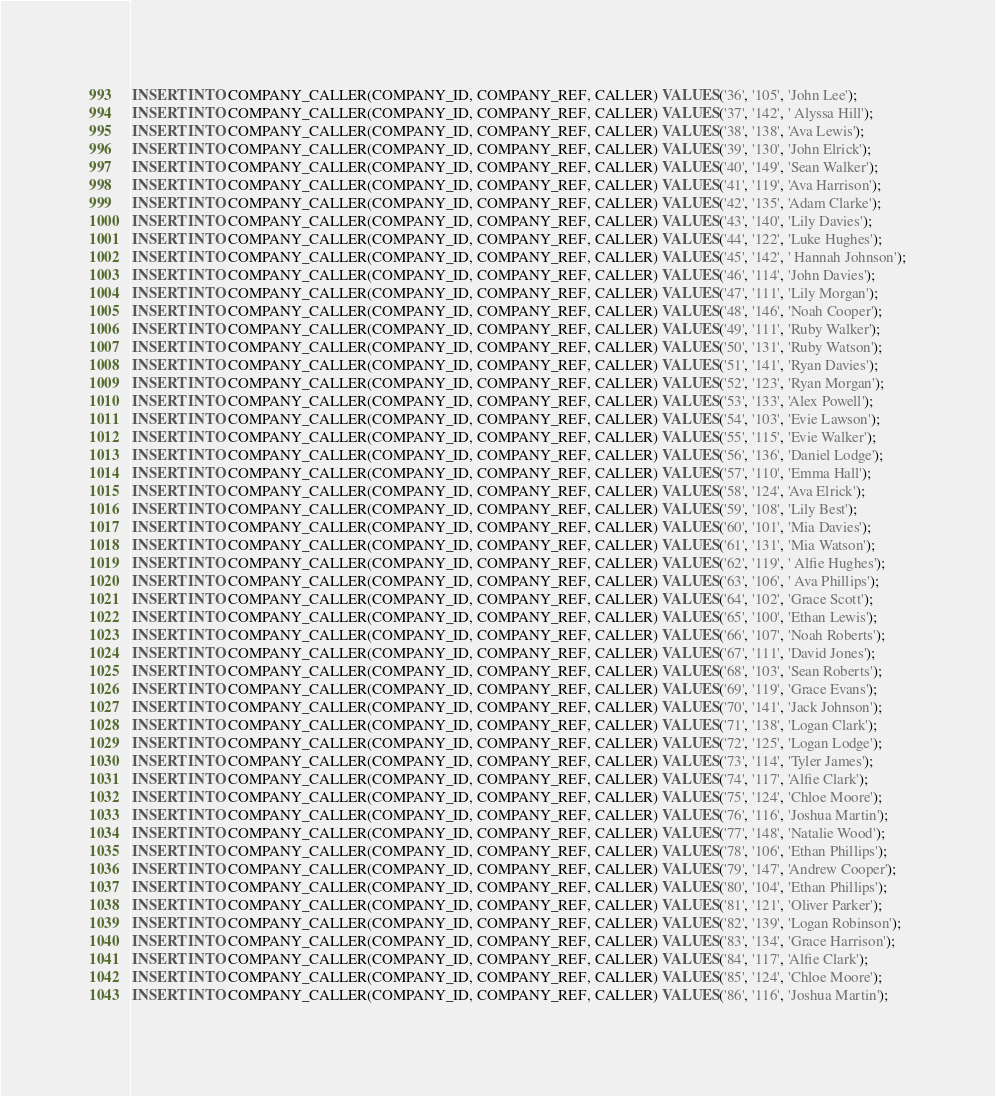<code> <loc_0><loc_0><loc_500><loc_500><_SQL_>INSERT INTO COMPANY_CALLER(COMPANY_ID, COMPANY_REF, CALLER) VALUES('36', '105', 'John Lee');
INSERT INTO COMPANY_CALLER(COMPANY_ID, COMPANY_REF, CALLER) VALUES('37', '142', ' Alyssa Hill');
INSERT INTO COMPANY_CALLER(COMPANY_ID, COMPANY_REF, CALLER) VALUES('38', '138', 'Ava Lewis');
INSERT INTO COMPANY_CALLER(COMPANY_ID, COMPANY_REF, CALLER) VALUES('39', '130', 'John Elrick');
INSERT INTO COMPANY_CALLER(COMPANY_ID, COMPANY_REF, CALLER) VALUES('40', '149', 'Sean Walker');
INSERT INTO COMPANY_CALLER(COMPANY_ID, COMPANY_REF, CALLER) VALUES('41', '119', 'Ava Harrison');
INSERT INTO COMPANY_CALLER(COMPANY_ID, COMPANY_REF, CALLER) VALUES('42', '135', 'Adam Clarke');
INSERT INTO COMPANY_CALLER(COMPANY_ID, COMPANY_REF, CALLER) VALUES('43', '140', 'Lily Davies');
INSERT INTO COMPANY_CALLER(COMPANY_ID, COMPANY_REF, CALLER) VALUES('44', '122', 'Luke Hughes');
INSERT INTO COMPANY_CALLER(COMPANY_ID, COMPANY_REF, CALLER) VALUES('45', '142', ' Hannah Johnson');
INSERT INTO COMPANY_CALLER(COMPANY_ID, COMPANY_REF, CALLER) VALUES('46', '114', 'John Davies');
INSERT INTO COMPANY_CALLER(COMPANY_ID, COMPANY_REF, CALLER) VALUES('47', '111', 'Lily Morgan');
INSERT INTO COMPANY_CALLER(COMPANY_ID, COMPANY_REF, CALLER) VALUES('48', '146', 'Noah Cooper');
INSERT INTO COMPANY_CALLER(COMPANY_ID, COMPANY_REF, CALLER) VALUES('49', '111', 'Ruby Walker');
INSERT INTO COMPANY_CALLER(COMPANY_ID, COMPANY_REF, CALLER) VALUES('50', '131', 'Ruby Watson');
INSERT INTO COMPANY_CALLER(COMPANY_ID, COMPANY_REF, CALLER) VALUES('51', '141', 'Ryan Davies');
INSERT INTO COMPANY_CALLER(COMPANY_ID, COMPANY_REF, CALLER) VALUES('52', '123', 'Ryan Morgan');
INSERT INTO COMPANY_CALLER(COMPANY_ID, COMPANY_REF, CALLER) VALUES('53', '133', 'Alex Powell');
INSERT INTO COMPANY_CALLER(COMPANY_ID, COMPANY_REF, CALLER) VALUES('54', '103', 'Evie Lawson');
INSERT INTO COMPANY_CALLER(COMPANY_ID, COMPANY_REF, CALLER) VALUES('55', '115', 'Evie Walker');
INSERT INTO COMPANY_CALLER(COMPANY_ID, COMPANY_REF, CALLER) VALUES('56', '136', 'Daniel Lodge');
INSERT INTO COMPANY_CALLER(COMPANY_ID, COMPANY_REF, CALLER) VALUES('57', '110', 'Emma Hall');
INSERT INTO COMPANY_CALLER(COMPANY_ID, COMPANY_REF, CALLER) VALUES('58', '124', 'Ava Elrick');
INSERT INTO COMPANY_CALLER(COMPANY_ID, COMPANY_REF, CALLER) VALUES('59', '108', 'Lily Best');
INSERT INTO COMPANY_CALLER(COMPANY_ID, COMPANY_REF, CALLER) VALUES('60', '101', 'Mia Davies');
INSERT INTO COMPANY_CALLER(COMPANY_ID, COMPANY_REF, CALLER) VALUES('61', '131', 'Mia Watson');
INSERT INTO COMPANY_CALLER(COMPANY_ID, COMPANY_REF, CALLER) VALUES('62', '119', ' Alfie Hughes');
INSERT INTO COMPANY_CALLER(COMPANY_ID, COMPANY_REF, CALLER) VALUES('63', '106', ' Ava Phillips');
INSERT INTO COMPANY_CALLER(COMPANY_ID, COMPANY_REF, CALLER) VALUES('64', '102', 'Grace Scott');
INSERT INTO COMPANY_CALLER(COMPANY_ID, COMPANY_REF, CALLER) VALUES('65', '100', 'Ethan Lewis');
INSERT INTO COMPANY_CALLER(COMPANY_ID, COMPANY_REF, CALLER) VALUES('66', '107', 'Noah Roberts');
INSERT INTO COMPANY_CALLER(COMPANY_ID, COMPANY_REF, CALLER) VALUES('67', '111', 'David Jones');
INSERT INTO COMPANY_CALLER(COMPANY_ID, COMPANY_REF, CALLER) VALUES('68', '103', 'Sean Roberts');
INSERT INTO COMPANY_CALLER(COMPANY_ID, COMPANY_REF, CALLER) VALUES('69', '119', 'Grace Evans');
INSERT INTO COMPANY_CALLER(COMPANY_ID, COMPANY_REF, CALLER) VALUES('70', '141', 'Jack Johnson');
INSERT INTO COMPANY_CALLER(COMPANY_ID, COMPANY_REF, CALLER) VALUES('71', '138', 'Logan Clark');
INSERT INTO COMPANY_CALLER(COMPANY_ID, COMPANY_REF, CALLER) VALUES('72', '125', 'Logan Lodge');
INSERT INTO COMPANY_CALLER(COMPANY_ID, COMPANY_REF, CALLER) VALUES('73', '114', 'Tyler James');
INSERT INTO COMPANY_CALLER(COMPANY_ID, COMPANY_REF, CALLER) VALUES('74', '117', 'Alfie Clark');
INSERT INTO COMPANY_CALLER(COMPANY_ID, COMPANY_REF, CALLER) VALUES('75', '124', 'Chloe Moore');
INSERT INTO COMPANY_CALLER(COMPANY_ID, COMPANY_REF, CALLER) VALUES('76', '116', 'Joshua Martin');
INSERT INTO COMPANY_CALLER(COMPANY_ID, COMPANY_REF, CALLER) VALUES('77', '148', 'Natalie Wood');
INSERT INTO COMPANY_CALLER(COMPANY_ID, COMPANY_REF, CALLER) VALUES('78', '106', 'Ethan Phillips');
INSERT INTO COMPANY_CALLER(COMPANY_ID, COMPANY_REF, CALLER) VALUES('79', '147', 'Andrew Cooper');
INSERT INTO COMPANY_CALLER(COMPANY_ID, COMPANY_REF, CALLER) VALUES('80', '104', 'Ethan Phillips');
INSERT INTO COMPANY_CALLER(COMPANY_ID, COMPANY_REF, CALLER) VALUES('81', '121', 'Oliver Parker');
INSERT INTO COMPANY_CALLER(COMPANY_ID, COMPANY_REF, CALLER) VALUES('82', '139', 'Logan Robinson');
INSERT INTO COMPANY_CALLER(COMPANY_ID, COMPANY_REF, CALLER) VALUES('83', '134', 'Grace Harrison');
INSERT INTO COMPANY_CALLER(COMPANY_ID, COMPANY_REF, CALLER) VALUES('84', '117', 'Alfie Clark');
INSERT INTO COMPANY_CALLER(COMPANY_ID, COMPANY_REF, CALLER) VALUES('85', '124', 'Chloe Moore');
INSERT INTO COMPANY_CALLER(COMPANY_ID, COMPANY_REF, CALLER) VALUES('86', '116', 'Joshua Martin');</code> 